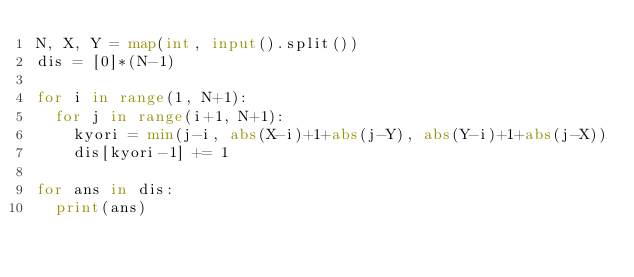<code> <loc_0><loc_0><loc_500><loc_500><_Python_>N, X, Y = map(int, input().split())
dis = [0]*(N-1)

for i in range(1, N+1):
  for j in range(i+1, N+1):
    kyori = min(j-i, abs(X-i)+1+abs(j-Y), abs(Y-i)+1+abs(j-X))
    dis[kyori-1] += 1
    
for ans in dis:
  print(ans)</code> 